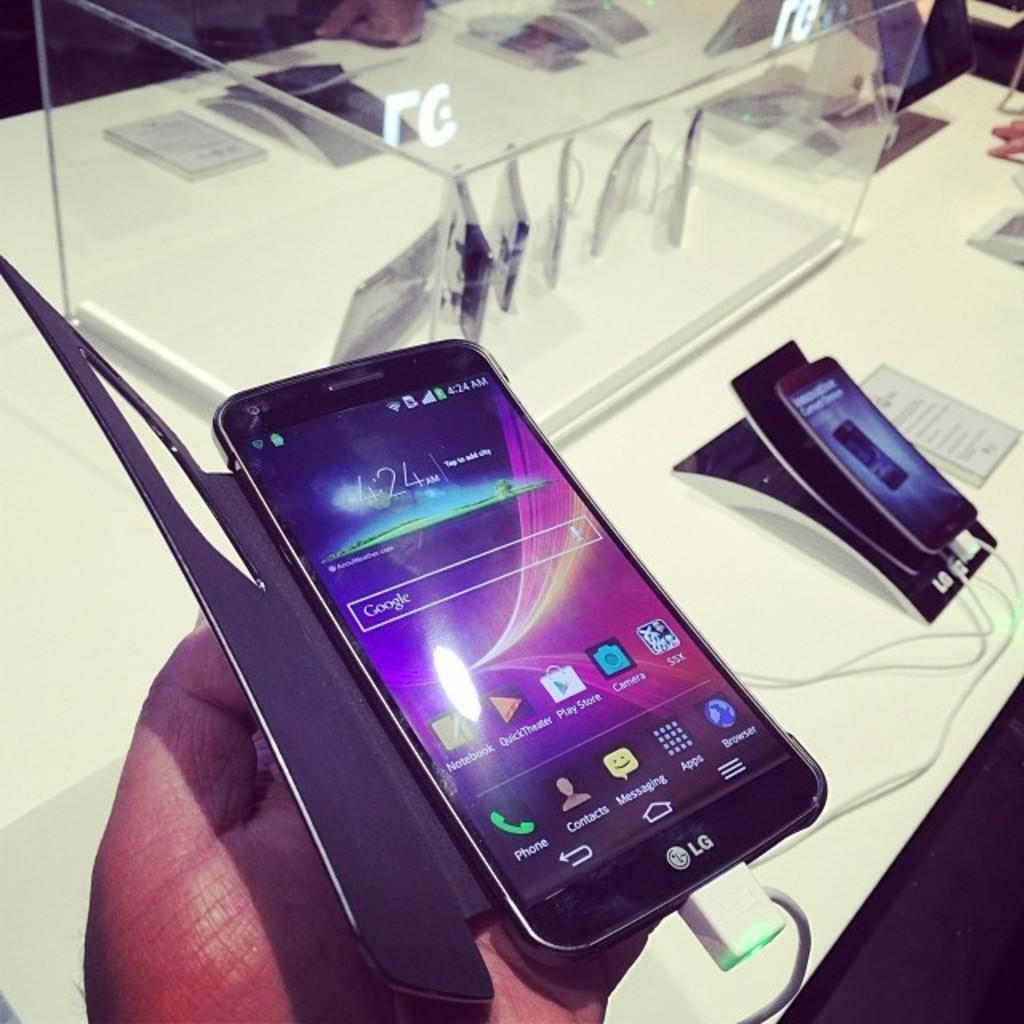<image>
Create a compact narrative representing the image presented. a phone that has a logo that says phone on it 